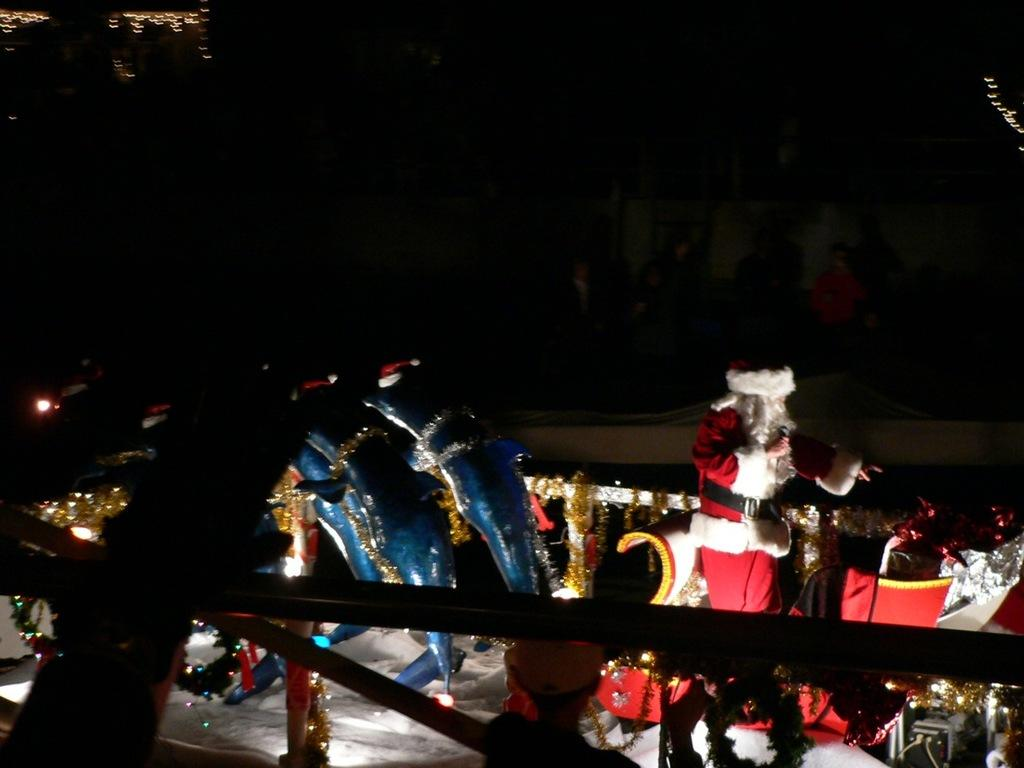Who or what is the main subject in the image? There is a person in the image. What other objects or characters are present in the image? There are toy dolphins with Christmas hats and a Santa Claus on a sleigh in the image. Can you describe the background of the image? The background of the image is dark. What type of fog can be seen in the image? There is no fog present in the image. 